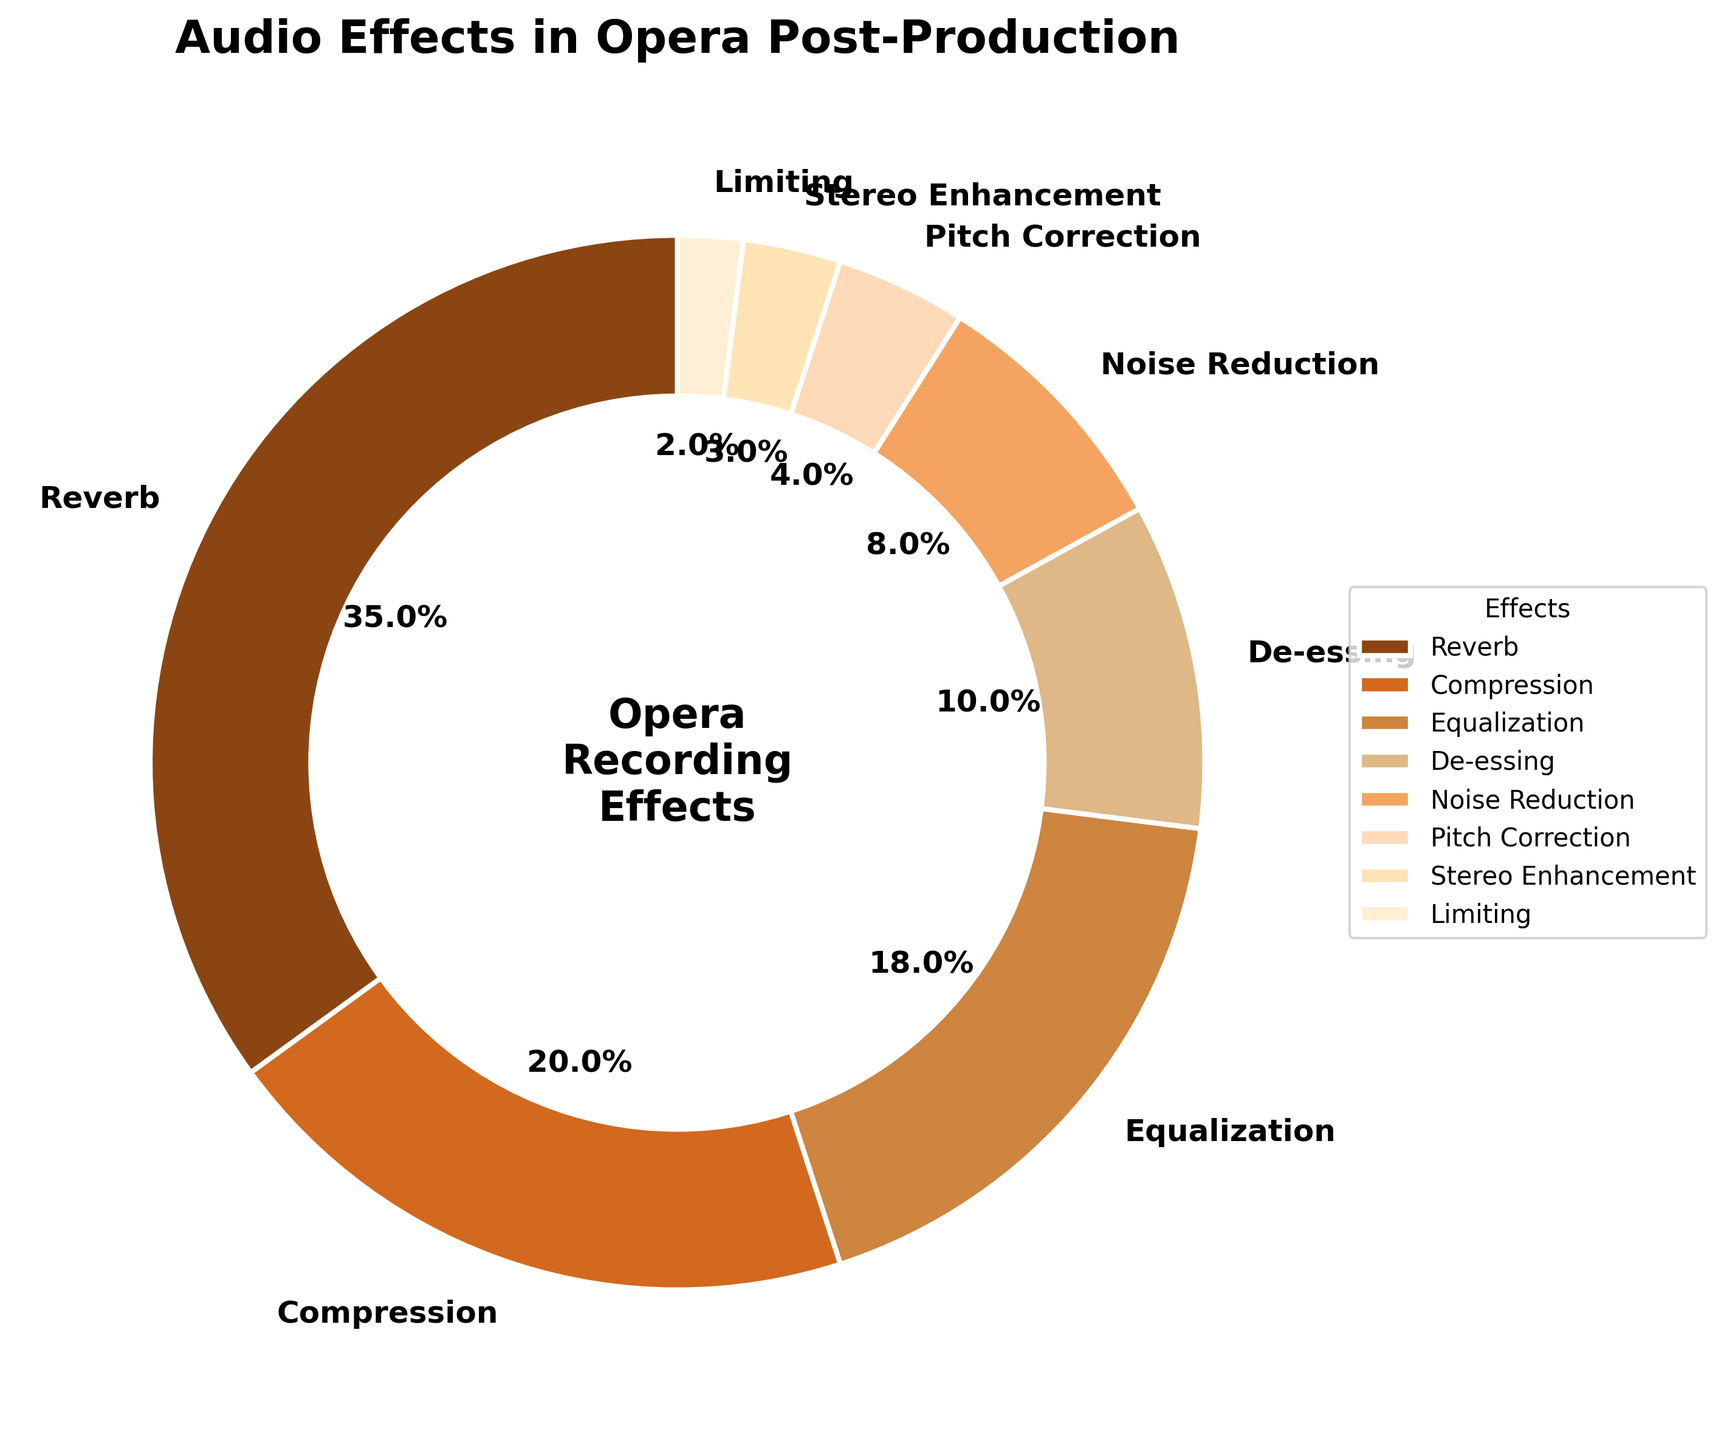What percentage of the pie chart is occupied by Compression and Equalization combined? To find the combined percentage, add the percentages of Compression and Equalization. Compression is 20%, and Equalization is 18%, so the total is 20% + 18% = 38%.
Answer: 38% Which audio effect has the smallest proportion, and what is its percentage? Identify the smallest segment from the pie chart, which is likely labeled as Limiting, and note the percentage shown in the label, which is 2%.
Answer: Limiting, 2% How does the proportion of Reverb compare to the proportion of De-essing? Look at the percentages for Reverb and De-essing. Reverb is 35%, while De-essing is 10%. Hence, Reverb is more than three times the proportion of De-essing.
Answer: Reverb > De-essing Among Pitch Correction, Stereo Enhancement, and Limiting, which has the highest percentage? Examine the percentages for Pitch Correction, Stereo Enhancement, and Limiting. Pitch Correction is 4%, Stereo Enhancement is 3%, and Limiting is 2%. Therefore, Pitch Correction has the highest percentage among the three.
Answer: Pitch Correction What is the difference in percentage between Noise Reduction and Compression? Subtract the percentage of Noise Reduction from the percentage of Compression. Compression is 20%, and Noise Reduction is 8%, so the difference is 20% - 8% = 12%.
Answer: 12% Which audio effect occupies the largest segment of the pie chart, and what is its percentage? Identify the largest segment from the pie chart, which is likely labeled as Reverb, and note the percentage shown in the label, which is 35%.
Answer: Reverb, 35% If you sum the percentages of the effects that are under 10%, what is the total percentage? Add the percentages of De-essing (10%), Noise Reduction (8%), Pitch Correction (4%), Stereo Enhancement (3%), and Limiting (2%). The total is 10% + 8% + 4% + 3% + 2% = 27%.
Answer: 27% Is the proportion of Equalization more than twice that of Stereo Enhancement? Compare the percentages of Equalization and Stereo Enhancement. Equalization is 18%, and Stereo Enhancement is 3%. Twice the proportion of Stereo Enhancement is 3% * 2 = 6%. Since 18% > 6%, the proportion of Equalization is indeed more than twice that of Stereo Enhancement.
Answer: Yes What is the combined percentage for Noise Reduction, Pitch Correction, and Stereo Enhancement? Add the percentages of Noise Reduction (8%), Pitch Correction (4%), and Stereo Enhancement (3%). The total is 8% + 4% + 3% = 15%.
Answer: 15% Which occupies a larger segment: Equalization or Noise Reduction? Compare the percentages for Equalization and Noise Reduction. Equalization is 18%, whereas Noise Reduction is 8%. Thus, Equalization occupies a larger segment.
Answer: Equalization 